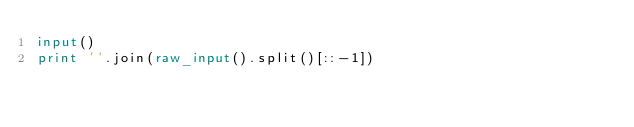Convert code to text. <code><loc_0><loc_0><loc_500><loc_500><_Python_>input()
print ''.join(raw_input().split()[::-1]) 
</code> 